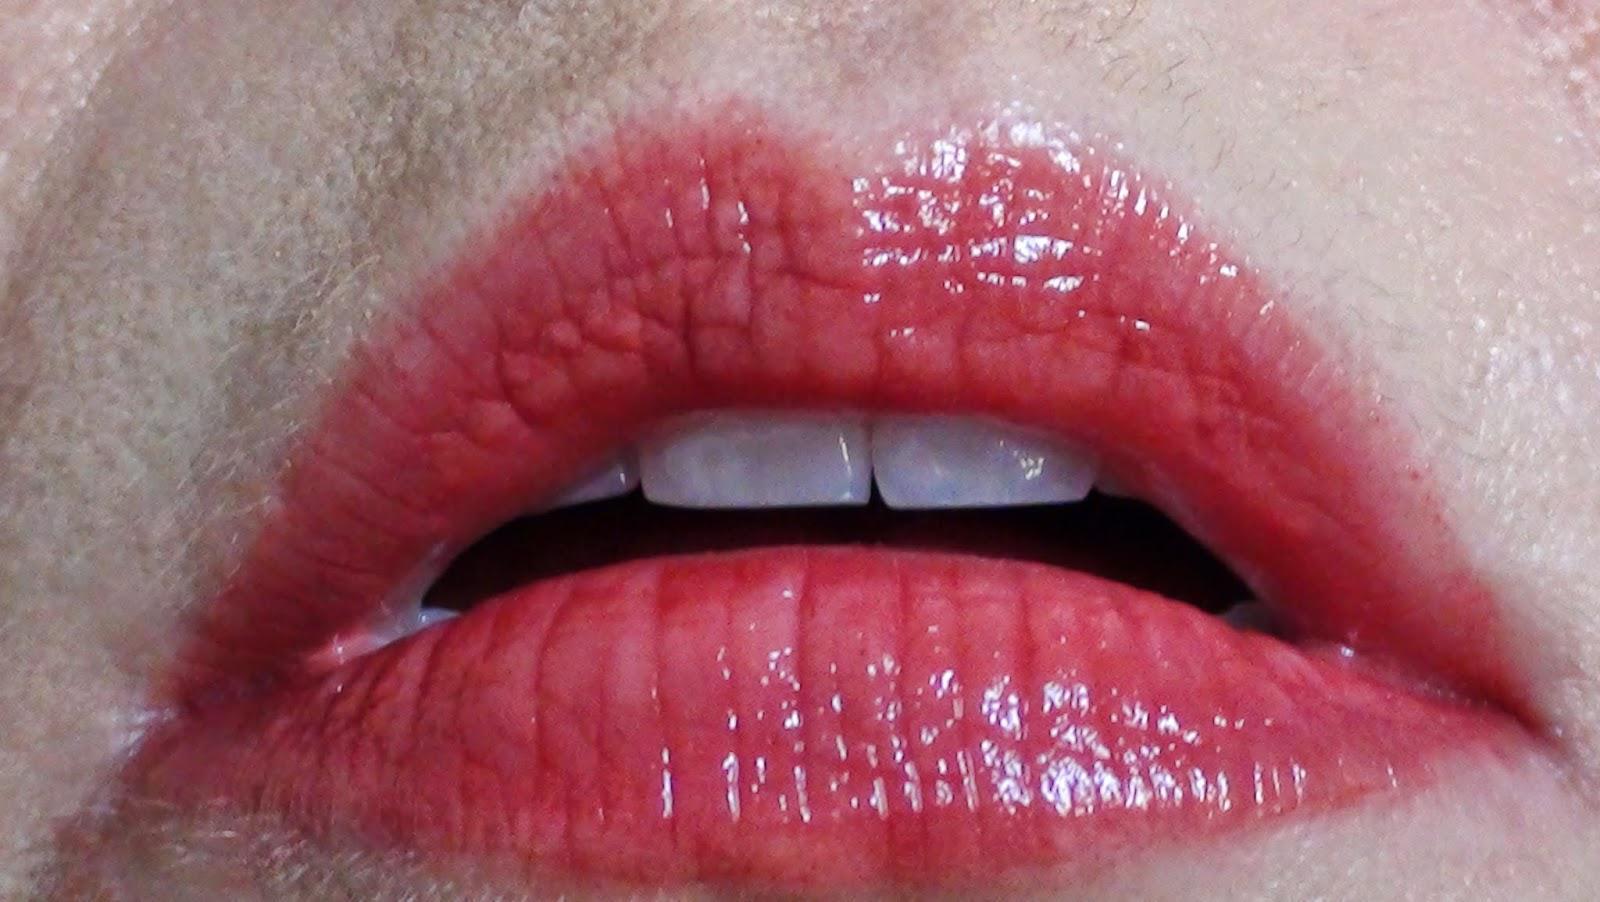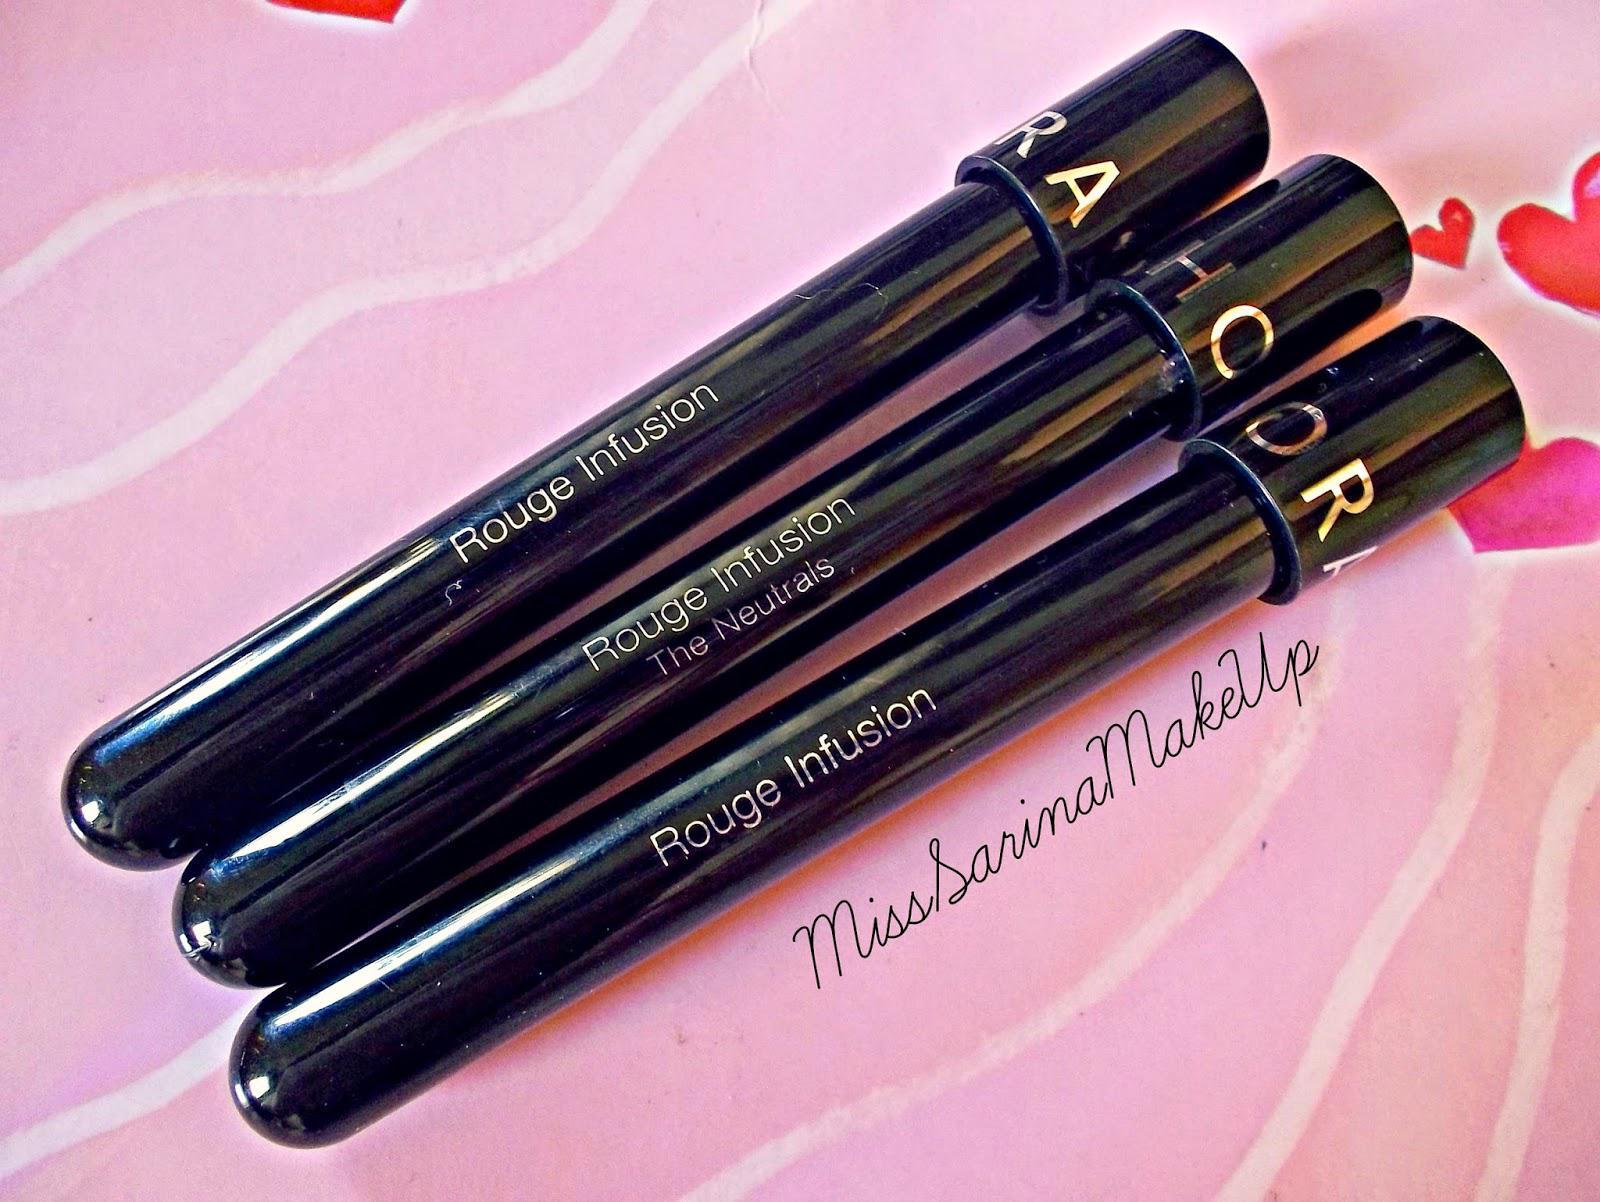The first image is the image on the left, the second image is the image on the right. Assess this claim about the two images: "There are three tubes of lipstick.". Correct or not? Answer yes or no. Yes. The first image is the image on the left, the second image is the image on the right. Analyze the images presented: Is the assertion "The lipstick is shown on a person's lips in at least one of the images." valid? Answer yes or no. Yes. 